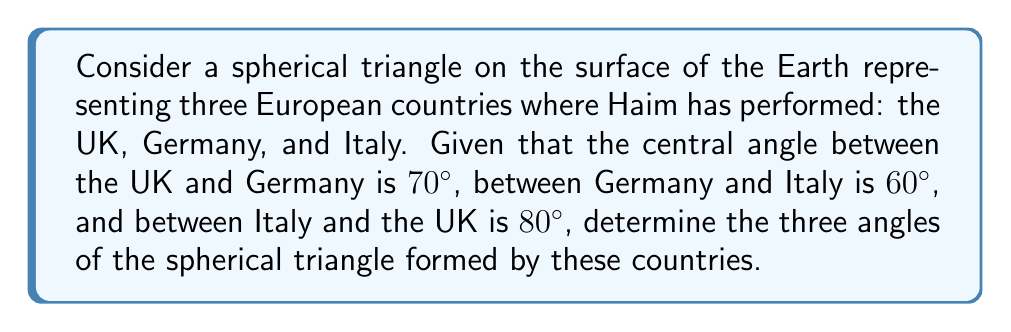Can you solve this math problem? Let's approach this step-by-step using the spherical law of cosines:

1) In a spherical triangle with sides $a$, $b$, and $c$, and opposite angles $A$, $B$, and $C$, the spherical law of cosines states:

   $$\cos a = \cos b \cos c + \sin b \sin c \cos A$$

2) We're given the central angles (which correspond to the sides of our spherical triangle):
   $a = 80°$, $b = 70°$, $c = 60°$

3) Let's find angle $A$ first. Rearranging the formula:

   $$\cos A = \frac{\cos a - \cos b \cos c}{\sin b \sin c}$$

4) Substituting our values:

   $$\cos A = \frac{\cos 80° - \cos 70° \cos 60°}{\sin 70° \sin 60°}$$

5) Calculating:
   
   $$\cos A = \frac{0.1736 - (0.3420 \times 0.5000)}{0.9397 \times 0.8660} = 0.2799$$

6) Taking the inverse cosine:

   $$A = \arccos(0.2799) \approx 73.7°$$

7) We can repeat this process for angles $B$ and $C$:

   For $B$: $$\cos B = \frac{\cos 70° - \cos 80° \cos 60°}{\sin 80° \sin 60°} \approx 0.3611$$
   $$B = \arccos(0.3611) \approx 68.8°$$

   For $C$: $$\cos C = \frac{\cos 60° - \cos 80° \cos 70°}{\sin 80° \sin 70°} \approx 0.4226$$
   $$C = \arccos(0.4226) \approx 65.0°$$

8) Therefore, the angles of our spherical triangle are approximately 73.7°, 68.8°, and 65.0°.
Answer: $A \approx 73.7°$, $B \approx 68.8°$, $C \approx 65.0°$ 